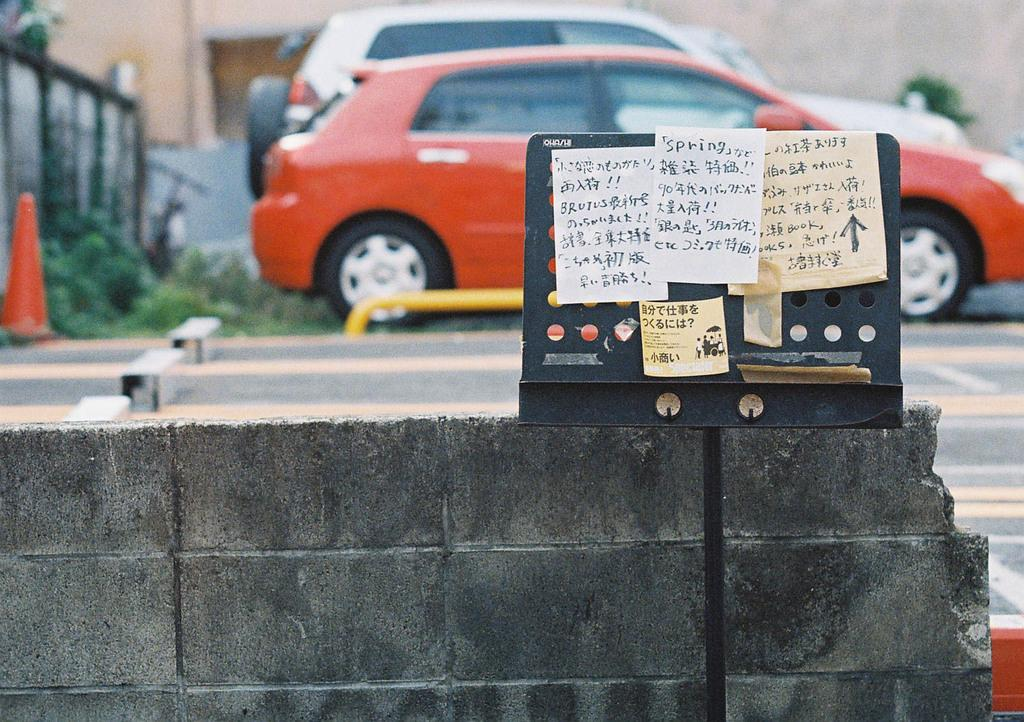What can be seen in the image that moves or transports people or goods? There are vehicles in the image that move or transport people or goods. What is visible on the ground in the image? The ground is visible in the image with some objects and grass. What type of structure can be seen in the image? There is a wall in the image. What is the black colored object with some posters in the image? The black colored object with some posters is likely a notice board or a wall with posters. What type of doll is being used in the class depicted in the image? There is no class or doll present in the image; it features vehicles, a wall, and a black colored object with posters. What part of the brain can be seen in the image? There is no part of the brain visible in the image. 